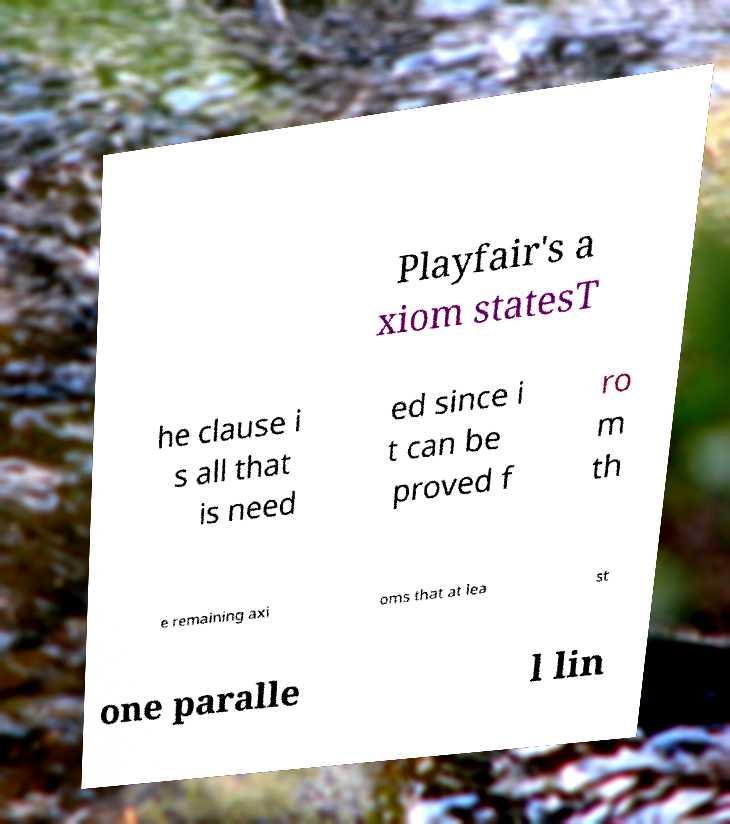Can you accurately transcribe the text from the provided image for me? Playfair's a xiom statesT he clause i s all that is need ed since i t can be proved f ro m th e remaining axi oms that at lea st one paralle l lin 